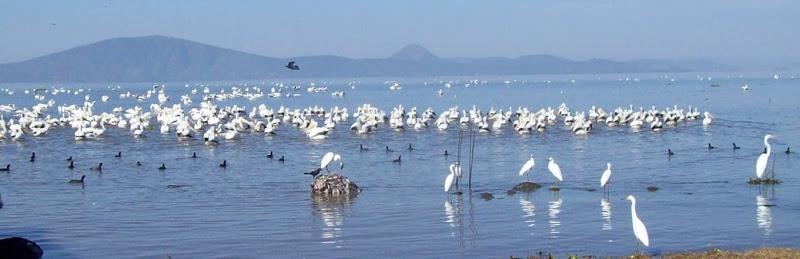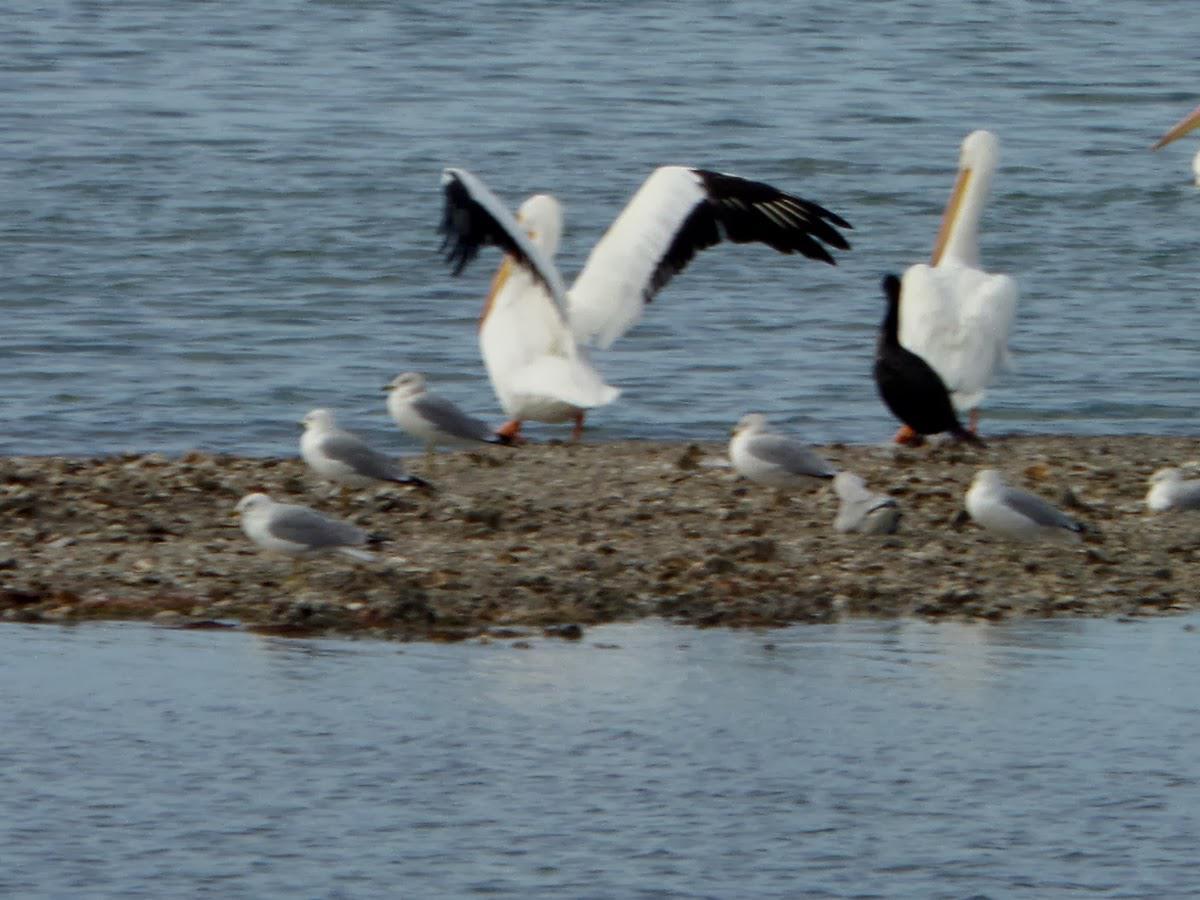The first image is the image on the left, the second image is the image on the right. Assess this claim about the two images: "An expanse of sandbar is visible under the pelicans.". Correct or not? Answer yes or no. Yes. 